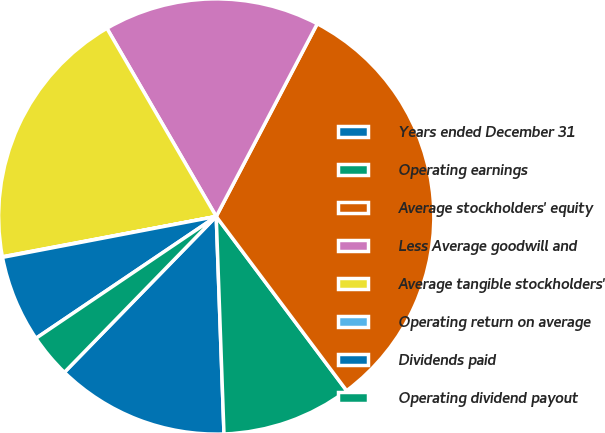<chart> <loc_0><loc_0><loc_500><loc_500><pie_chart><fcel>Years ended December 31<fcel>Operating earnings<fcel>Average stockholders' equity<fcel>Less Average goodwill and<fcel>Average tangible stockholders'<fcel>Operating return on average<fcel>Dividends paid<fcel>Operating dividend payout<nl><fcel>12.86%<fcel>9.66%<fcel>32.09%<fcel>16.06%<fcel>19.59%<fcel>0.04%<fcel>6.45%<fcel>3.25%<nl></chart> 